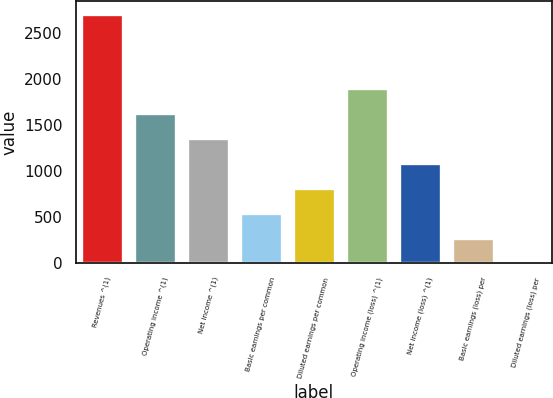<chart> <loc_0><loc_0><loc_500><loc_500><bar_chart><fcel>Revenues ^(1)<fcel>Operating income ^(1)<fcel>Net income ^(1)<fcel>Basic earnings per common<fcel>Diluted earnings per common<fcel>Operating income (loss) ^(1)<fcel>Net income (loss) ^(1)<fcel>Basic earnings (loss) per<fcel>Diluted earnings (loss) per<nl><fcel>2706<fcel>1623.8<fcel>1353.24<fcel>541.56<fcel>812.12<fcel>1894.36<fcel>1082.68<fcel>271<fcel>0.44<nl></chart> 